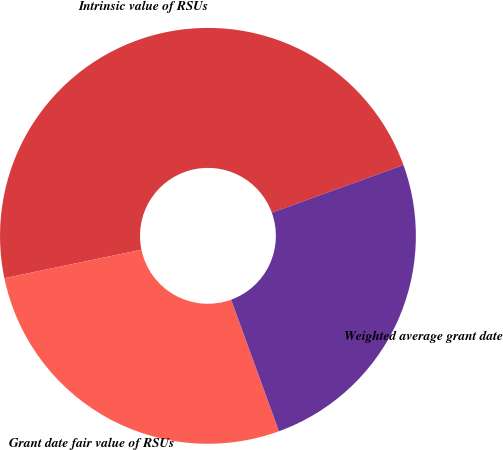Convert chart. <chart><loc_0><loc_0><loc_500><loc_500><pie_chart><fcel>Intrinsic value of RSUs<fcel>Grant date fair value of RSUs<fcel>Weighted average grant date<nl><fcel>47.74%<fcel>27.28%<fcel>24.98%<nl></chart> 